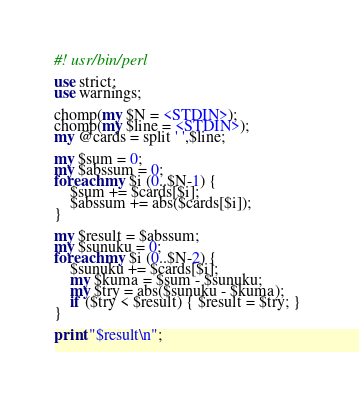<code> <loc_0><loc_0><loc_500><loc_500><_Perl_>#! usr/bin/perl

use strict;
use warnings;

chomp(my $N = <STDIN>);
chomp(my $line = <STDIN>);
my @cards = split ' ',$line;

my $sum = 0;
my $abssum = 0;
foreach my $i (0..$N-1) {
    $sum += $cards[$i];
    $abssum += abs($cards[$i]);
}

my $result = $abssum;
my $sunuku = 0;
foreach my $i (0..$N-2) {
    $sunuku += $cards[$i];
    my $kuma = $sum - $sunuku;
    my $try = abs($sunuku - $kuma);
    if ($try < $result) { $result = $try; } 
}

print "$result\n";</code> 